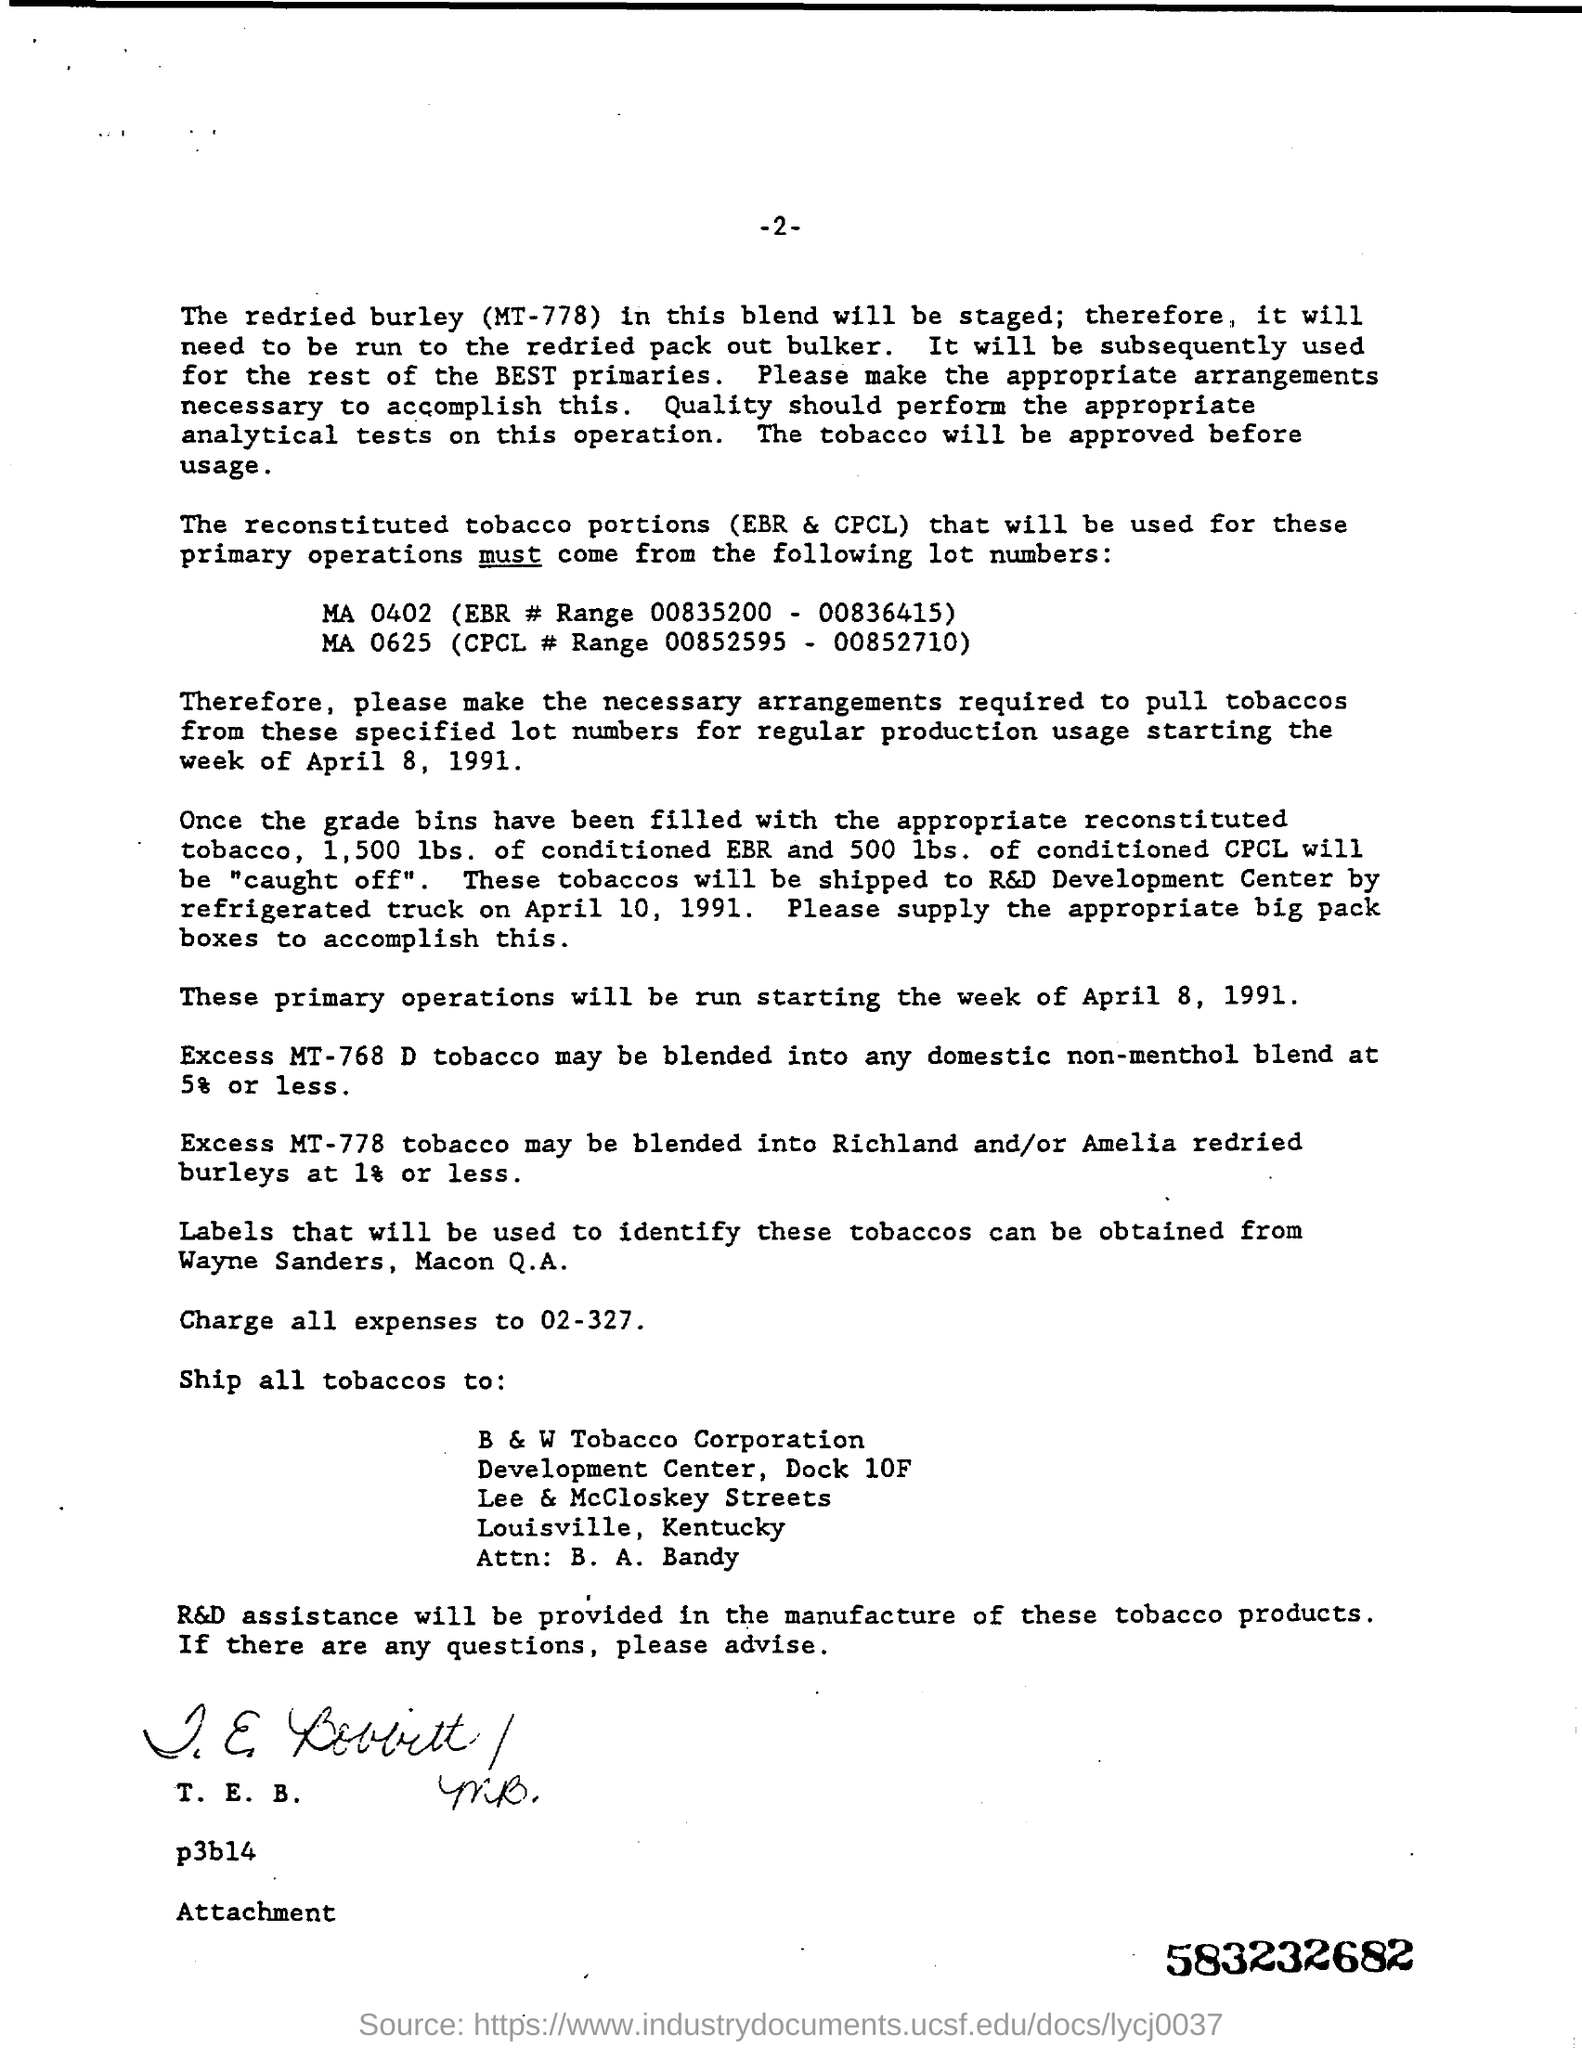Whose assistance will be provided in the manufacture of these tobacco products?
Your response must be concise. R&D Assistance. Where is the tobacco being shipped to?
Offer a very short reply. B&W Tobacco Corporation, Development Center, Dock 10F, Lee & McCloskey Streets, Louisville , Kentucky. Where can be the labels used to identify these tobaccos obtained?
Offer a terse response. Wayne Sanders, Macon Q.A. 